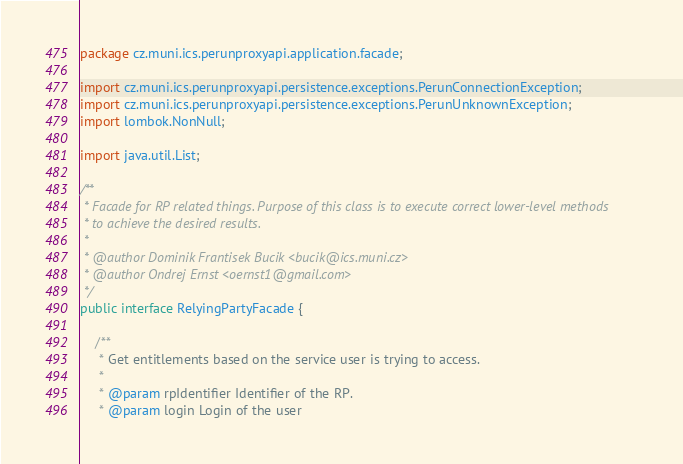Convert code to text. <code><loc_0><loc_0><loc_500><loc_500><_Java_>package cz.muni.ics.perunproxyapi.application.facade;

import cz.muni.ics.perunproxyapi.persistence.exceptions.PerunConnectionException;
import cz.muni.ics.perunproxyapi.persistence.exceptions.PerunUnknownException;
import lombok.NonNull;

import java.util.List;

/**
 * Facade for RP related things. Purpose of this class is to execute correct lower-level methods
 * to achieve the desired results.
 *
 * @author Dominik Frantisek Bucik <bucik@ics.muni.cz>
 * @author Ondrej Ernst <oernst1@gmail.com>
 */
public interface RelyingPartyFacade {

    /**
     * Get entitlements based on the service user is trying to access.
     *
     * @param rpIdentifier Identifier of the RP.
     * @param login Login of the user</code> 